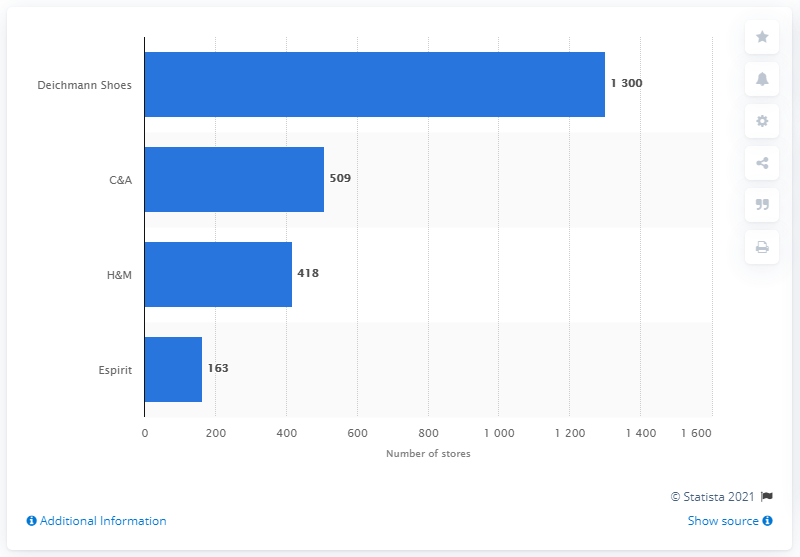List a handful of essential elements in this visual. According to data obtained in 2013, Deichmann Shoes was the shoe brand with the highest number of stores in Germany. In 2013, C&A had a total of 509 stores in Germany. 